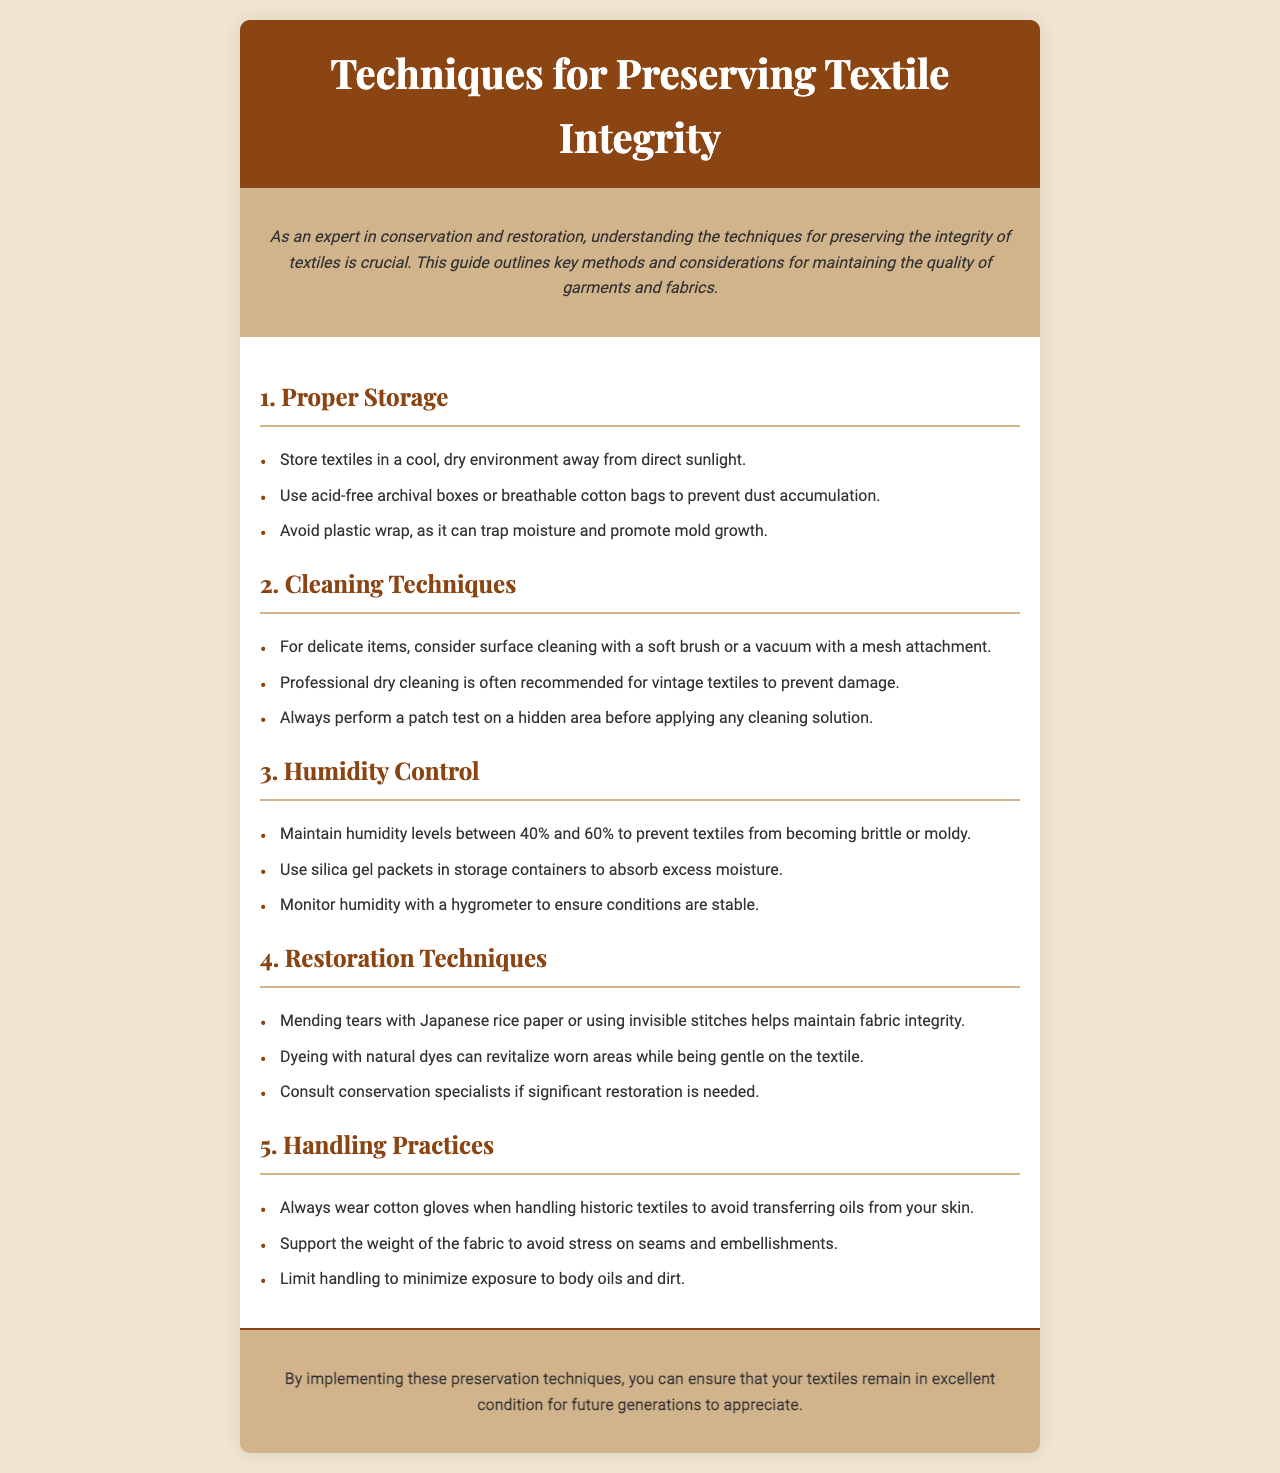what is the main purpose of the brochure? The brochure outlines key methods and considerations for maintaining the quality of garments and fabrics.
Answer: preserving textile integrity what is the recommended humidity level range for textiles? The document mentions maintaining humidity levels between 40% and 60% to prevent damage to textiles.
Answer: 40% and 60% what type of storage containers should be used for textiles? The brochure advises using acid-free archival boxes or breathable cotton bags to prevent dust accumulation.
Answer: acid-free archival boxes or breathable cotton bags which material is suggested for mending tears? The document recommends mending tears with Japanese rice paper to help maintain fabric integrity.
Answer: Japanese rice paper how can excess moisture be absorbed in storage containers? The brochure suggests using silica gel packets in storage containers for moisture control.
Answer: silica gel packets why should plastic wrap be avoided for textile storage? The document states that plastic wrap can trap moisture, leading to mold growth.
Answer: trap moisture what is a recommended cleaning method for delicate textiles? The brochure mentions considering surface cleaning with a soft brush or a vacuum with a mesh attachment for delicate items.
Answer: surface cleaning with a soft brush what should be monitored to ensure stable conditions for textiles? The document advises monitoring humidity with a hygrometer to ensure stable conditions.
Answer: hygrometer what is the final message of the brochure? The conclusion emphasizes understanding and implementing preservation techniques to maintain textile condition for future generations.
Answer: excellent condition for future generations 